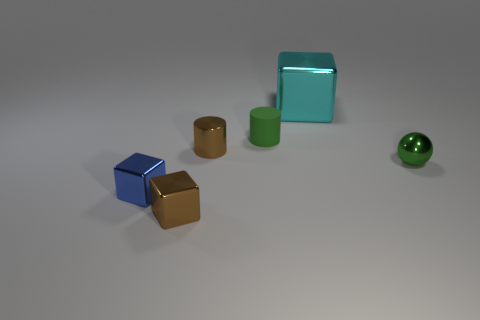Add 2 tiny green spheres. How many objects exist? 8 Subtract all small cubes. How many cubes are left? 1 Subtract all spheres. How many objects are left? 5 Add 5 large yellow metal cylinders. How many large yellow metal cylinders exist? 5 Subtract 1 brown cubes. How many objects are left? 5 Subtract all big yellow blocks. Subtract all brown things. How many objects are left? 4 Add 6 tiny blue blocks. How many tiny blue blocks are left? 7 